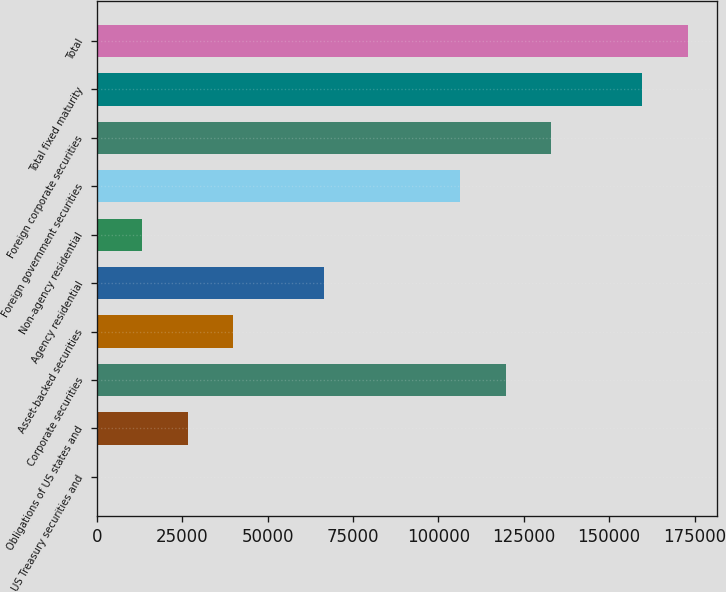<chart> <loc_0><loc_0><loc_500><loc_500><bar_chart><fcel>US Treasury securities and<fcel>Obligations of US states and<fcel>Corporate securities<fcel>Asset-backed securities<fcel>Agency residential<fcel>Non-agency residential<fcel>Foreign government securities<fcel>Foreign corporate securities<fcel>Total fixed maturity<fcel>Total<nl><fcel>6<fcel>26618.4<fcel>119762<fcel>39924.6<fcel>66537<fcel>13312.2<fcel>106456<fcel>133068<fcel>159680<fcel>172987<nl></chart> 